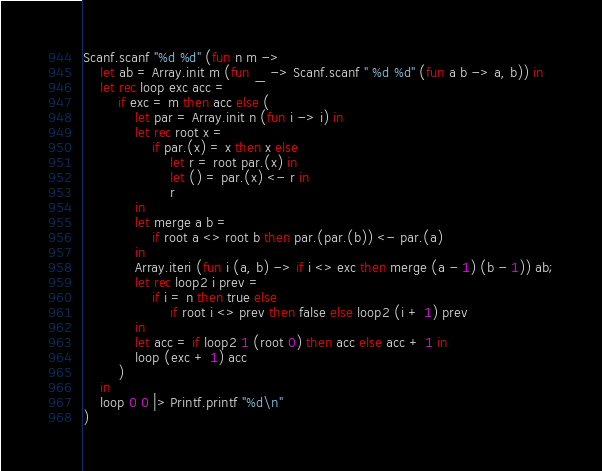Convert code to text. <code><loc_0><loc_0><loc_500><loc_500><_OCaml_>Scanf.scanf "%d %d" (fun n m ->
    let ab = Array.init m (fun _ -> Scanf.scanf " %d %d" (fun a b -> a, b)) in
    let rec loop exc acc =
        if exc = m then acc else (
            let par = Array.init n (fun i -> i) in
            let rec root x =
                if par.(x) = x then x else
                    let r = root par.(x) in
                    let () = par.(x) <- r in
                    r
            in
            let merge a b =
                if root a <> root b then par.(par.(b)) <- par.(a)
            in
            Array.iteri (fun i (a, b) -> if i <> exc then merge (a - 1) (b - 1)) ab;
            let rec loop2 i prev =
                if i = n then true else
                    if root i <> prev then false else loop2 (i + 1) prev
            in
            let acc = if loop2 1 (root 0) then acc else acc + 1 in
            loop (exc + 1) acc
        )
    in
    loop 0 0 |> Printf.printf "%d\n"
)</code> 